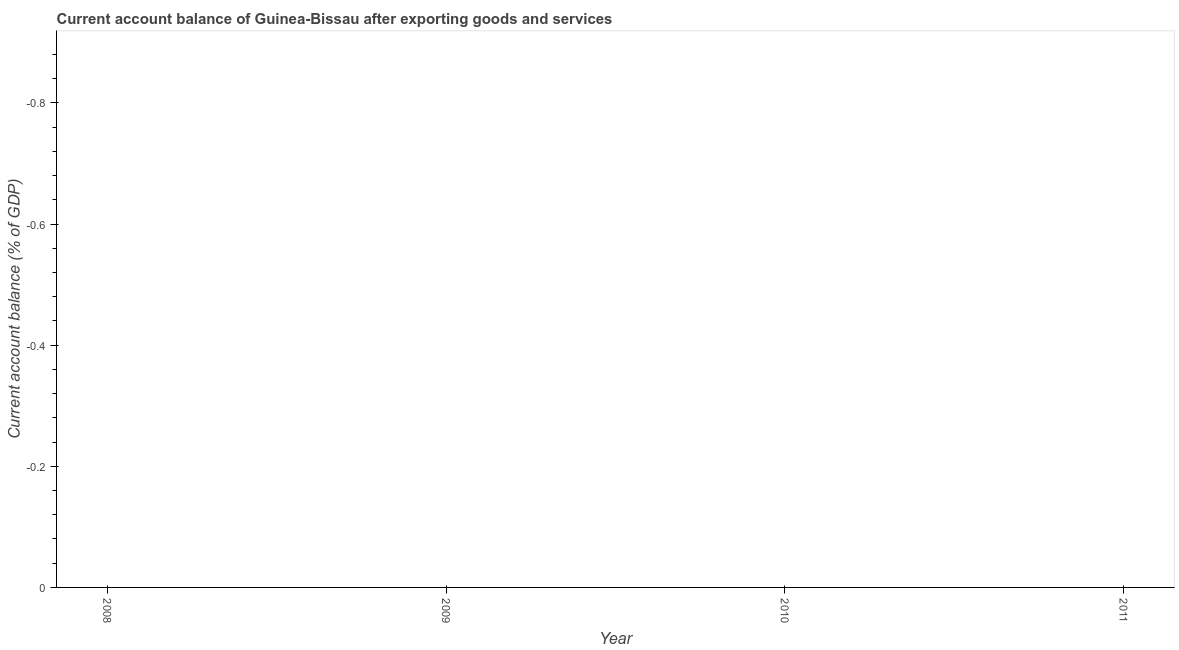What is the current account balance in 2008?
Provide a succinct answer. 0. What is the sum of the current account balance?
Your answer should be compact. 0. What is the median current account balance?
Keep it short and to the point. 0. In how many years, is the current account balance greater than the average current account balance taken over all years?
Offer a terse response. 0. How many lines are there?
Provide a short and direct response. 0. How many years are there in the graph?
Your answer should be compact. 4. What is the difference between two consecutive major ticks on the Y-axis?
Your response must be concise. 0.2. Does the graph contain any zero values?
Your answer should be very brief. Yes. What is the title of the graph?
Offer a very short reply. Current account balance of Guinea-Bissau after exporting goods and services. What is the label or title of the X-axis?
Keep it short and to the point. Year. What is the label or title of the Y-axis?
Provide a short and direct response. Current account balance (% of GDP). What is the Current account balance (% of GDP) in 2009?
Your answer should be compact. 0. 